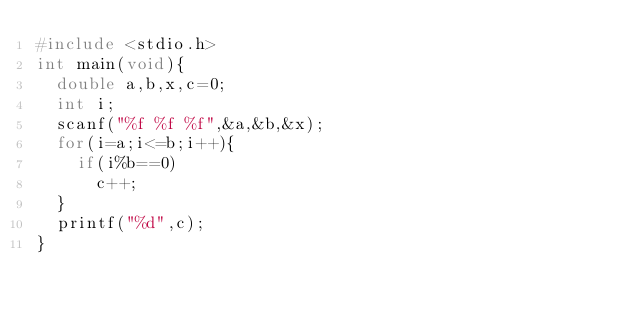<code> <loc_0><loc_0><loc_500><loc_500><_C++_>#include <stdio.h>
int main(void){
  double a,b,x,c=0;
  int i;
  scanf("%f %f %f",&a,&b,&x);
  for(i=a;i<=b;i++){
	if(i%b==0)
      c++;
  }
  printf("%d",c);
}
</code> 